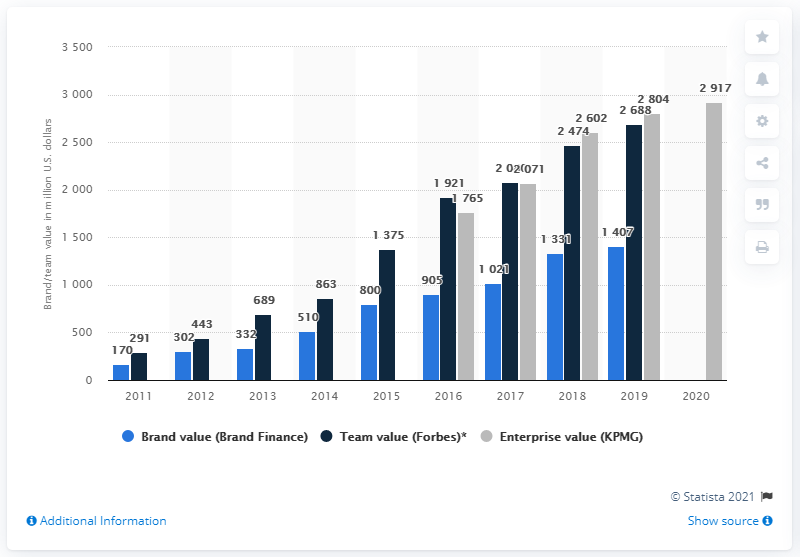Outline some significant characteristics in this image. Manchester City's brand value in dollars in 2019 was 1,407. 